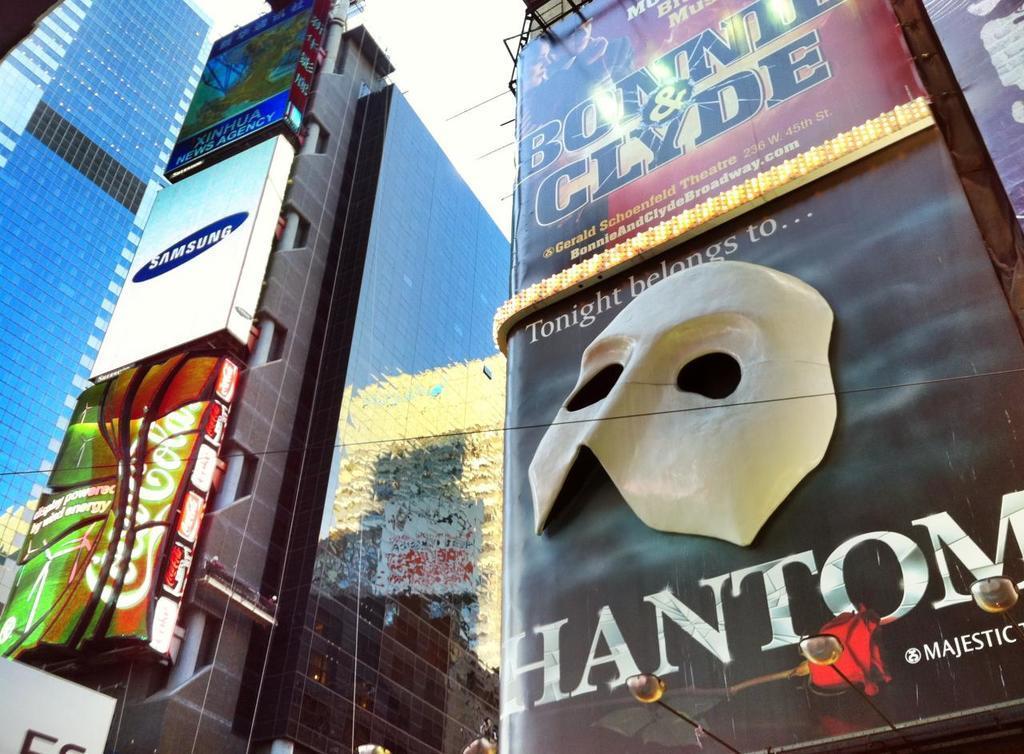Describe this image in one or two sentences. In this picture I can observe buildings. There are advertisements on the walls of the buildings. In the background I can observe sky. 